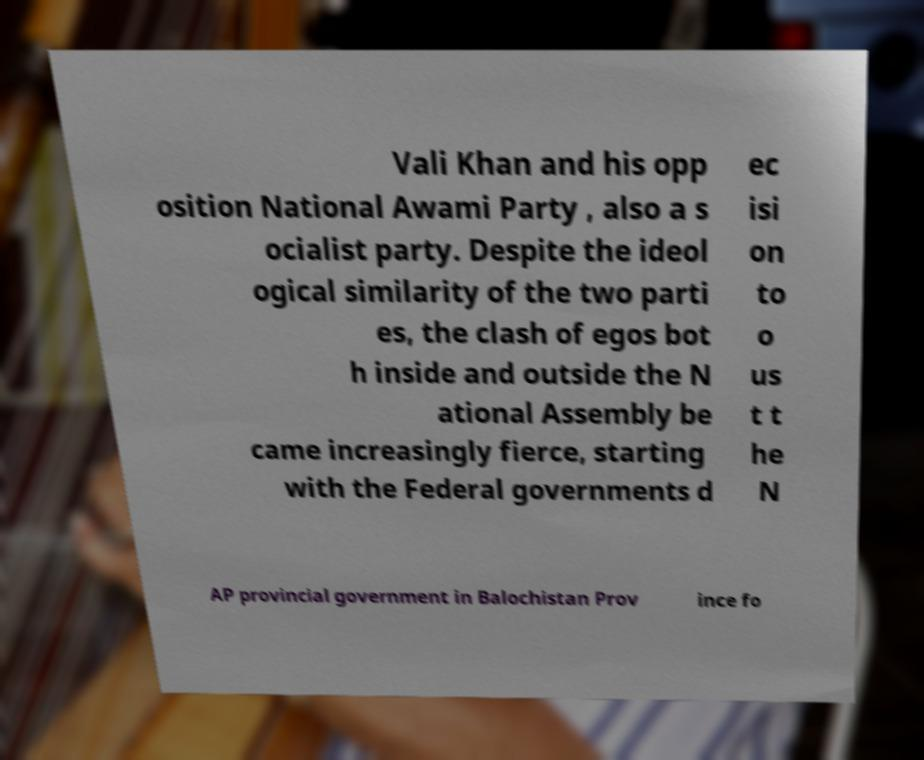Please identify and transcribe the text found in this image. Vali Khan and his opp osition National Awami Party , also a s ocialist party. Despite the ideol ogical similarity of the two parti es, the clash of egos bot h inside and outside the N ational Assembly be came increasingly fierce, starting with the Federal governments d ec isi on to o us t t he N AP provincial government in Balochistan Prov ince fo 